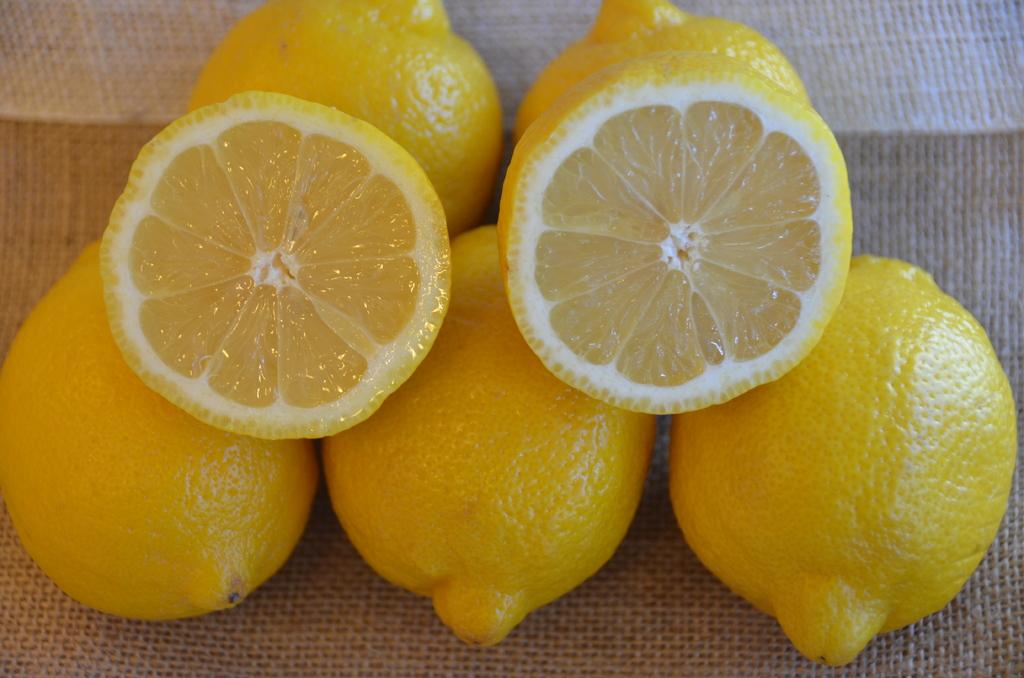What type of fruit is present in the image? There are lemons in the image. What is the surface on which the lemons are placed? The lemons are on a jute surface. What type of donkey can be seen carrying a copper notebook in the image? There is no donkey or copper notebook present in the image; it only features lemons on a jute surface. 